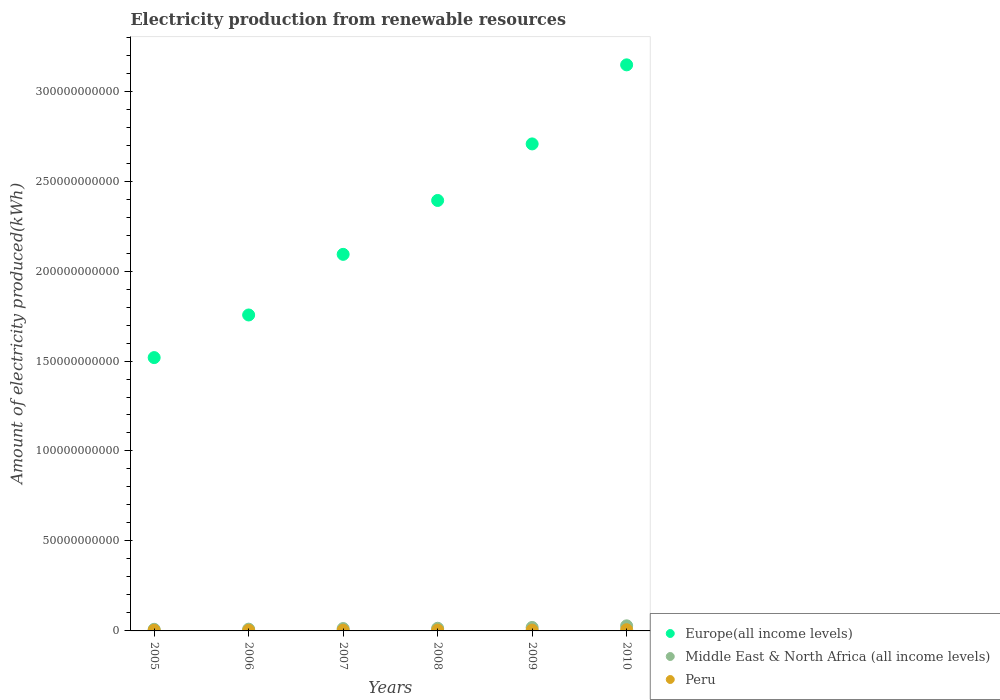Is the number of dotlines equal to the number of legend labels?
Ensure brevity in your answer.  Yes. What is the amount of electricity produced in Europe(all income levels) in 2007?
Give a very brief answer. 2.09e+11. Across all years, what is the maximum amount of electricity produced in Peru?
Provide a short and direct response. 6.74e+08. Across all years, what is the minimum amount of electricity produced in Peru?
Give a very brief answer. 3.49e+08. What is the total amount of electricity produced in Middle East & North Africa (all income levels) in the graph?
Keep it short and to the point. 9.42e+09. What is the difference between the amount of electricity produced in Middle East & North Africa (all income levels) in 2006 and that in 2008?
Your answer should be very brief. -4.93e+08. What is the difference between the amount of electricity produced in Middle East & North Africa (all income levels) in 2006 and the amount of electricity produced in Europe(all income levels) in 2009?
Make the answer very short. -2.70e+11. What is the average amount of electricity produced in Europe(all income levels) per year?
Ensure brevity in your answer.  2.27e+11. In the year 2009, what is the difference between the amount of electricity produced in Middle East & North Africa (all income levels) and amount of electricity produced in Europe(all income levels)?
Keep it short and to the point. -2.69e+11. What is the ratio of the amount of electricity produced in Europe(all income levels) in 2005 to that in 2010?
Your answer should be very brief. 0.48. Is the amount of electricity produced in Peru in 2007 less than that in 2010?
Keep it short and to the point. Yes. Is the difference between the amount of electricity produced in Middle East & North Africa (all income levels) in 2005 and 2010 greater than the difference between the amount of electricity produced in Europe(all income levels) in 2005 and 2010?
Your answer should be compact. Yes. What is the difference between the highest and the second highest amount of electricity produced in Middle East & North Africa (all income levels)?
Keep it short and to the point. 8.95e+08. What is the difference between the highest and the lowest amount of electricity produced in Middle East & North Africa (all income levels)?
Your response must be concise. 1.94e+09. In how many years, is the amount of electricity produced in Peru greater than the average amount of electricity produced in Peru taken over all years?
Provide a succinct answer. 3. Is the sum of the amount of electricity produced in Middle East & North Africa (all income levels) in 2007 and 2010 greater than the maximum amount of electricity produced in Peru across all years?
Make the answer very short. Yes. Does the amount of electricity produced in Europe(all income levels) monotonically increase over the years?
Provide a short and direct response. Yes. Is the amount of electricity produced in Peru strictly greater than the amount of electricity produced in Europe(all income levels) over the years?
Provide a short and direct response. No. How many dotlines are there?
Provide a short and direct response. 3. How many years are there in the graph?
Give a very brief answer. 6. Are the values on the major ticks of Y-axis written in scientific E-notation?
Provide a succinct answer. No. Where does the legend appear in the graph?
Keep it short and to the point. Bottom right. What is the title of the graph?
Give a very brief answer. Electricity production from renewable resources. What is the label or title of the X-axis?
Offer a very short reply. Years. What is the label or title of the Y-axis?
Offer a very short reply. Amount of electricity produced(kWh). What is the Amount of electricity produced(kWh) in Europe(all income levels) in 2005?
Ensure brevity in your answer.  1.52e+11. What is the Amount of electricity produced(kWh) in Middle East & North Africa (all income levels) in 2005?
Provide a short and direct response. 8.90e+08. What is the Amount of electricity produced(kWh) in Peru in 2005?
Offer a very short reply. 3.49e+08. What is the Amount of electricity produced(kWh) in Europe(all income levels) in 2006?
Make the answer very short. 1.76e+11. What is the Amount of electricity produced(kWh) of Middle East & North Africa (all income levels) in 2006?
Your answer should be compact. 9.81e+08. What is the Amount of electricity produced(kWh) of Peru in 2006?
Your answer should be compact. 3.49e+08. What is the Amount of electricity produced(kWh) of Europe(all income levels) in 2007?
Your answer should be very brief. 2.09e+11. What is the Amount of electricity produced(kWh) of Middle East & North Africa (all income levels) in 2007?
Give a very brief answer. 1.32e+09. What is the Amount of electricity produced(kWh) in Peru in 2007?
Your answer should be very brief. 4.18e+08. What is the Amount of electricity produced(kWh) of Europe(all income levels) in 2008?
Your answer should be very brief. 2.39e+11. What is the Amount of electricity produced(kWh) in Middle East & North Africa (all income levels) in 2008?
Offer a very short reply. 1.47e+09. What is the Amount of electricity produced(kWh) in Peru in 2008?
Your response must be concise. 4.61e+08. What is the Amount of electricity produced(kWh) in Europe(all income levels) in 2009?
Your answer should be compact. 2.71e+11. What is the Amount of electricity produced(kWh) in Middle East & North Africa (all income levels) in 2009?
Your response must be concise. 1.93e+09. What is the Amount of electricity produced(kWh) of Peru in 2009?
Your answer should be compact. 4.61e+08. What is the Amount of electricity produced(kWh) of Europe(all income levels) in 2010?
Offer a very short reply. 3.15e+11. What is the Amount of electricity produced(kWh) of Middle East & North Africa (all income levels) in 2010?
Offer a very short reply. 2.83e+09. What is the Amount of electricity produced(kWh) of Peru in 2010?
Offer a terse response. 6.74e+08. Across all years, what is the maximum Amount of electricity produced(kWh) in Europe(all income levels)?
Your response must be concise. 3.15e+11. Across all years, what is the maximum Amount of electricity produced(kWh) of Middle East & North Africa (all income levels)?
Provide a short and direct response. 2.83e+09. Across all years, what is the maximum Amount of electricity produced(kWh) in Peru?
Ensure brevity in your answer.  6.74e+08. Across all years, what is the minimum Amount of electricity produced(kWh) in Europe(all income levels)?
Keep it short and to the point. 1.52e+11. Across all years, what is the minimum Amount of electricity produced(kWh) of Middle East & North Africa (all income levels)?
Provide a short and direct response. 8.90e+08. Across all years, what is the minimum Amount of electricity produced(kWh) of Peru?
Provide a succinct answer. 3.49e+08. What is the total Amount of electricity produced(kWh) in Europe(all income levels) in the graph?
Ensure brevity in your answer.  1.36e+12. What is the total Amount of electricity produced(kWh) of Middle East & North Africa (all income levels) in the graph?
Ensure brevity in your answer.  9.42e+09. What is the total Amount of electricity produced(kWh) in Peru in the graph?
Give a very brief answer. 2.71e+09. What is the difference between the Amount of electricity produced(kWh) in Europe(all income levels) in 2005 and that in 2006?
Ensure brevity in your answer.  -2.37e+1. What is the difference between the Amount of electricity produced(kWh) of Middle East & North Africa (all income levels) in 2005 and that in 2006?
Offer a terse response. -9.10e+07. What is the difference between the Amount of electricity produced(kWh) in Peru in 2005 and that in 2006?
Ensure brevity in your answer.  0. What is the difference between the Amount of electricity produced(kWh) of Europe(all income levels) in 2005 and that in 2007?
Give a very brief answer. -5.74e+1. What is the difference between the Amount of electricity produced(kWh) in Middle East & North Africa (all income levels) in 2005 and that in 2007?
Ensure brevity in your answer.  -4.29e+08. What is the difference between the Amount of electricity produced(kWh) in Peru in 2005 and that in 2007?
Your answer should be very brief. -6.90e+07. What is the difference between the Amount of electricity produced(kWh) of Europe(all income levels) in 2005 and that in 2008?
Offer a terse response. -8.73e+1. What is the difference between the Amount of electricity produced(kWh) in Middle East & North Africa (all income levels) in 2005 and that in 2008?
Your response must be concise. -5.84e+08. What is the difference between the Amount of electricity produced(kWh) in Peru in 2005 and that in 2008?
Provide a succinct answer. -1.12e+08. What is the difference between the Amount of electricity produced(kWh) of Europe(all income levels) in 2005 and that in 2009?
Offer a very short reply. -1.19e+11. What is the difference between the Amount of electricity produced(kWh) of Middle East & North Africa (all income levels) in 2005 and that in 2009?
Give a very brief answer. -1.04e+09. What is the difference between the Amount of electricity produced(kWh) of Peru in 2005 and that in 2009?
Your answer should be very brief. -1.12e+08. What is the difference between the Amount of electricity produced(kWh) of Europe(all income levels) in 2005 and that in 2010?
Offer a terse response. -1.63e+11. What is the difference between the Amount of electricity produced(kWh) of Middle East & North Africa (all income levels) in 2005 and that in 2010?
Ensure brevity in your answer.  -1.94e+09. What is the difference between the Amount of electricity produced(kWh) of Peru in 2005 and that in 2010?
Your answer should be very brief. -3.25e+08. What is the difference between the Amount of electricity produced(kWh) in Europe(all income levels) in 2006 and that in 2007?
Your answer should be very brief. -3.37e+1. What is the difference between the Amount of electricity produced(kWh) in Middle East & North Africa (all income levels) in 2006 and that in 2007?
Your answer should be very brief. -3.38e+08. What is the difference between the Amount of electricity produced(kWh) in Peru in 2006 and that in 2007?
Give a very brief answer. -6.90e+07. What is the difference between the Amount of electricity produced(kWh) in Europe(all income levels) in 2006 and that in 2008?
Ensure brevity in your answer.  -6.36e+1. What is the difference between the Amount of electricity produced(kWh) of Middle East & North Africa (all income levels) in 2006 and that in 2008?
Provide a succinct answer. -4.93e+08. What is the difference between the Amount of electricity produced(kWh) of Peru in 2006 and that in 2008?
Your answer should be very brief. -1.12e+08. What is the difference between the Amount of electricity produced(kWh) of Europe(all income levels) in 2006 and that in 2009?
Ensure brevity in your answer.  -9.51e+1. What is the difference between the Amount of electricity produced(kWh) of Middle East & North Africa (all income levels) in 2006 and that in 2009?
Give a very brief answer. -9.52e+08. What is the difference between the Amount of electricity produced(kWh) of Peru in 2006 and that in 2009?
Provide a succinct answer. -1.12e+08. What is the difference between the Amount of electricity produced(kWh) in Europe(all income levels) in 2006 and that in 2010?
Ensure brevity in your answer.  -1.39e+11. What is the difference between the Amount of electricity produced(kWh) of Middle East & North Africa (all income levels) in 2006 and that in 2010?
Keep it short and to the point. -1.85e+09. What is the difference between the Amount of electricity produced(kWh) in Peru in 2006 and that in 2010?
Provide a short and direct response. -3.25e+08. What is the difference between the Amount of electricity produced(kWh) in Europe(all income levels) in 2007 and that in 2008?
Give a very brief answer. -3.00e+1. What is the difference between the Amount of electricity produced(kWh) of Middle East & North Africa (all income levels) in 2007 and that in 2008?
Offer a terse response. -1.55e+08. What is the difference between the Amount of electricity produced(kWh) of Peru in 2007 and that in 2008?
Offer a very short reply. -4.30e+07. What is the difference between the Amount of electricity produced(kWh) of Europe(all income levels) in 2007 and that in 2009?
Offer a terse response. -6.14e+1. What is the difference between the Amount of electricity produced(kWh) in Middle East & North Africa (all income levels) in 2007 and that in 2009?
Provide a short and direct response. -6.14e+08. What is the difference between the Amount of electricity produced(kWh) of Peru in 2007 and that in 2009?
Provide a succinct answer. -4.30e+07. What is the difference between the Amount of electricity produced(kWh) in Europe(all income levels) in 2007 and that in 2010?
Your answer should be very brief. -1.05e+11. What is the difference between the Amount of electricity produced(kWh) in Middle East & North Africa (all income levels) in 2007 and that in 2010?
Your answer should be compact. -1.51e+09. What is the difference between the Amount of electricity produced(kWh) of Peru in 2007 and that in 2010?
Make the answer very short. -2.56e+08. What is the difference between the Amount of electricity produced(kWh) in Europe(all income levels) in 2008 and that in 2009?
Provide a short and direct response. -3.14e+1. What is the difference between the Amount of electricity produced(kWh) in Middle East & North Africa (all income levels) in 2008 and that in 2009?
Offer a very short reply. -4.59e+08. What is the difference between the Amount of electricity produced(kWh) of Peru in 2008 and that in 2009?
Provide a succinct answer. 0. What is the difference between the Amount of electricity produced(kWh) in Europe(all income levels) in 2008 and that in 2010?
Keep it short and to the point. -7.54e+1. What is the difference between the Amount of electricity produced(kWh) of Middle East & North Africa (all income levels) in 2008 and that in 2010?
Provide a succinct answer. -1.35e+09. What is the difference between the Amount of electricity produced(kWh) of Peru in 2008 and that in 2010?
Offer a terse response. -2.13e+08. What is the difference between the Amount of electricity produced(kWh) in Europe(all income levels) in 2009 and that in 2010?
Offer a very short reply. -4.39e+1. What is the difference between the Amount of electricity produced(kWh) in Middle East & North Africa (all income levels) in 2009 and that in 2010?
Ensure brevity in your answer.  -8.95e+08. What is the difference between the Amount of electricity produced(kWh) in Peru in 2009 and that in 2010?
Provide a short and direct response. -2.13e+08. What is the difference between the Amount of electricity produced(kWh) of Europe(all income levels) in 2005 and the Amount of electricity produced(kWh) of Middle East & North Africa (all income levels) in 2006?
Your answer should be very brief. 1.51e+11. What is the difference between the Amount of electricity produced(kWh) of Europe(all income levels) in 2005 and the Amount of electricity produced(kWh) of Peru in 2006?
Make the answer very short. 1.52e+11. What is the difference between the Amount of electricity produced(kWh) in Middle East & North Africa (all income levels) in 2005 and the Amount of electricity produced(kWh) in Peru in 2006?
Your response must be concise. 5.41e+08. What is the difference between the Amount of electricity produced(kWh) of Europe(all income levels) in 2005 and the Amount of electricity produced(kWh) of Middle East & North Africa (all income levels) in 2007?
Provide a short and direct response. 1.51e+11. What is the difference between the Amount of electricity produced(kWh) of Europe(all income levels) in 2005 and the Amount of electricity produced(kWh) of Peru in 2007?
Your answer should be very brief. 1.51e+11. What is the difference between the Amount of electricity produced(kWh) in Middle East & North Africa (all income levels) in 2005 and the Amount of electricity produced(kWh) in Peru in 2007?
Ensure brevity in your answer.  4.72e+08. What is the difference between the Amount of electricity produced(kWh) in Europe(all income levels) in 2005 and the Amount of electricity produced(kWh) in Middle East & North Africa (all income levels) in 2008?
Keep it short and to the point. 1.50e+11. What is the difference between the Amount of electricity produced(kWh) of Europe(all income levels) in 2005 and the Amount of electricity produced(kWh) of Peru in 2008?
Offer a very short reply. 1.51e+11. What is the difference between the Amount of electricity produced(kWh) of Middle East & North Africa (all income levels) in 2005 and the Amount of electricity produced(kWh) of Peru in 2008?
Your answer should be very brief. 4.29e+08. What is the difference between the Amount of electricity produced(kWh) of Europe(all income levels) in 2005 and the Amount of electricity produced(kWh) of Middle East & North Africa (all income levels) in 2009?
Provide a short and direct response. 1.50e+11. What is the difference between the Amount of electricity produced(kWh) of Europe(all income levels) in 2005 and the Amount of electricity produced(kWh) of Peru in 2009?
Make the answer very short. 1.51e+11. What is the difference between the Amount of electricity produced(kWh) in Middle East & North Africa (all income levels) in 2005 and the Amount of electricity produced(kWh) in Peru in 2009?
Ensure brevity in your answer.  4.29e+08. What is the difference between the Amount of electricity produced(kWh) in Europe(all income levels) in 2005 and the Amount of electricity produced(kWh) in Middle East & North Africa (all income levels) in 2010?
Provide a succinct answer. 1.49e+11. What is the difference between the Amount of electricity produced(kWh) in Europe(all income levels) in 2005 and the Amount of electricity produced(kWh) in Peru in 2010?
Your answer should be very brief. 1.51e+11. What is the difference between the Amount of electricity produced(kWh) of Middle East & North Africa (all income levels) in 2005 and the Amount of electricity produced(kWh) of Peru in 2010?
Offer a very short reply. 2.16e+08. What is the difference between the Amount of electricity produced(kWh) of Europe(all income levels) in 2006 and the Amount of electricity produced(kWh) of Middle East & North Africa (all income levels) in 2007?
Ensure brevity in your answer.  1.74e+11. What is the difference between the Amount of electricity produced(kWh) of Europe(all income levels) in 2006 and the Amount of electricity produced(kWh) of Peru in 2007?
Offer a very short reply. 1.75e+11. What is the difference between the Amount of electricity produced(kWh) of Middle East & North Africa (all income levels) in 2006 and the Amount of electricity produced(kWh) of Peru in 2007?
Your answer should be very brief. 5.63e+08. What is the difference between the Amount of electricity produced(kWh) in Europe(all income levels) in 2006 and the Amount of electricity produced(kWh) in Middle East & North Africa (all income levels) in 2008?
Give a very brief answer. 1.74e+11. What is the difference between the Amount of electricity produced(kWh) in Europe(all income levels) in 2006 and the Amount of electricity produced(kWh) in Peru in 2008?
Offer a very short reply. 1.75e+11. What is the difference between the Amount of electricity produced(kWh) in Middle East & North Africa (all income levels) in 2006 and the Amount of electricity produced(kWh) in Peru in 2008?
Provide a short and direct response. 5.20e+08. What is the difference between the Amount of electricity produced(kWh) of Europe(all income levels) in 2006 and the Amount of electricity produced(kWh) of Middle East & North Africa (all income levels) in 2009?
Keep it short and to the point. 1.74e+11. What is the difference between the Amount of electricity produced(kWh) in Europe(all income levels) in 2006 and the Amount of electricity produced(kWh) in Peru in 2009?
Keep it short and to the point. 1.75e+11. What is the difference between the Amount of electricity produced(kWh) in Middle East & North Africa (all income levels) in 2006 and the Amount of electricity produced(kWh) in Peru in 2009?
Ensure brevity in your answer.  5.20e+08. What is the difference between the Amount of electricity produced(kWh) in Europe(all income levels) in 2006 and the Amount of electricity produced(kWh) in Middle East & North Africa (all income levels) in 2010?
Give a very brief answer. 1.73e+11. What is the difference between the Amount of electricity produced(kWh) in Europe(all income levels) in 2006 and the Amount of electricity produced(kWh) in Peru in 2010?
Keep it short and to the point. 1.75e+11. What is the difference between the Amount of electricity produced(kWh) of Middle East & North Africa (all income levels) in 2006 and the Amount of electricity produced(kWh) of Peru in 2010?
Your answer should be compact. 3.07e+08. What is the difference between the Amount of electricity produced(kWh) of Europe(all income levels) in 2007 and the Amount of electricity produced(kWh) of Middle East & North Africa (all income levels) in 2008?
Your answer should be very brief. 2.08e+11. What is the difference between the Amount of electricity produced(kWh) in Europe(all income levels) in 2007 and the Amount of electricity produced(kWh) in Peru in 2008?
Ensure brevity in your answer.  2.09e+11. What is the difference between the Amount of electricity produced(kWh) of Middle East & North Africa (all income levels) in 2007 and the Amount of electricity produced(kWh) of Peru in 2008?
Keep it short and to the point. 8.58e+08. What is the difference between the Amount of electricity produced(kWh) in Europe(all income levels) in 2007 and the Amount of electricity produced(kWh) in Middle East & North Africa (all income levels) in 2009?
Give a very brief answer. 2.07e+11. What is the difference between the Amount of electricity produced(kWh) in Europe(all income levels) in 2007 and the Amount of electricity produced(kWh) in Peru in 2009?
Ensure brevity in your answer.  2.09e+11. What is the difference between the Amount of electricity produced(kWh) in Middle East & North Africa (all income levels) in 2007 and the Amount of electricity produced(kWh) in Peru in 2009?
Your response must be concise. 8.58e+08. What is the difference between the Amount of electricity produced(kWh) in Europe(all income levels) in 2007 and the Amount of electricity produced(kWh) in Middle East & North Africa (all income levels) in 2010?
Provide a succinct answer. 2.06e+11. What is the difference between the Amount of electricity produced(kWh) of Europe(all income levels) in 2007 and the Amount of electricity produced(kWh) of Peru in 2010?
Your answer should be very brief. 2.09e+11. What is the difference between the Amount of electricity produced(kWh) of Middle East & North Africa (all income levels) in 2007 and the Amount of electricity produced(kWh) of Peru in 2010?
Offer a very short reply. 6.45e+08. What is the difference between the Amount of electricity produced(kWh) of Europe(all income levels) in 2008 and the Amount of electricity produced(kWh) of Middle East & North Africa (all income levels) in 2009?
Your answer should be very brief. 2.37e+11. What is the difference between the Amount of electricity produced(kWh) of Europe(all income levels) in 2008 and the Amount of electricity produced(kWh) of Peru in 2009?
Provide a succinct answer. 2.39e+11. What is the difference between the Amount of electricity produced(kWh) of Middle East & North Africa (all income levels) in 2008 and the Amount of electricity produced(kWh) of Peru in 2009?
Offer a terse response. 1.01e+09. What is the difference between the Amount of electricity produced(kWh) in Europe(all income levels) in 2008 and the Amount of electricity produced(kWh) in Middle East & North Africa (all income levels) in 2010?
Your answer should be compact. 2.36e+11. What is the difference between the Amount of electricity produced(kWh) of Europe(all income levels) in 2008 and the Amount of electricity produced(kWh) of Peru in 2010?
Keep it short and to the point. 2.39e+11. What is the difference between the Amount of electricity produced(kWh) of Middle East & North Africa (all income levels) in 2008 and the Amount of electricity produced(kWh) of Peru in 2010?
Provide a succinct answer. 8.00e+08. What is the difference between the Amount of electricity produced(kWh) in Europe(all income levels) in 2009 and the Amount of electricity produced(kWh) in Middle East & North Africa (all income levels) in 2010?
Offer a terse response. 2.68e+11. What is the difference between the Amount of electricity produced(kWh) of Europe(all income levels) in 2009 and the Amount of electricity produced(kWh) of Peru in 2010?
Your answer should be very brief. 2.70e+11. What is the difference between the Amount of electricity produced(kWh) in Middle East & North Africa (all income levels) in 2009 and the Amount of electricity produced(kWh) in Peru in 2010?
Offer a very short reply. 1.26e+09. What is the average Amount of electricity produced(kWh) of Europe(all income levels) per year?
Give a very brief answer. 2.27e+11. What is the average Amount of electricity produced(kWh) of Middle East & North Africa (all income levels) per year?
Ensure brevity in your answer.  1.57e+09. What is the average Amount of electricity produced(kWh) of Peru per year?
Offer a terse response. 4.52e+08. In the year 2005, what is the difference between the Amount of electricity produced(kWh) in Europe(all income levels) and Amount of electricity produced(kWh) in Middle East & North Africa (all income levels)?
Offer a very short reply. 1.51e+11. In the year 2005, what is the difference between the Amount of electricity produced(kWh) in Europe(all income levels) and Amount of electricity produced(kWh) in Peru?
Offer a very short reply. 1.52e+11. In the year 2005, what is the difference between the Amount of electricity produced(kWh) in Middle East & North Africa (all income levels) and Amount of electricity produced(kWh) in Peru?
Make the answer very short. 5.41e+08. In the year 2006, what is the difference between the Amount of electricity produced(kWh) in Europe(all income levels) and Amount of electricity produced(kWh) in Middle East & North Africa (all income levels)?
Offer a terse response. 1.75e+11. In the year 2006, what is the difference between the Amount of electricity produced(kWh) in Europe(all income levels) and Amount of electricity produced(kWh) in Peru?
Make the answer very short. 1.75e+11. In the year 2006, what is the difference between the Amount of electricity produced(kWh) of Middle East & North Africa (all income levels) and Amount of electricity produced(kWh) of Peru?
Ensure brevity in your answer.  6.32e+08. In the year 2007, what is the difference between the Amount of electricity produced(kWh) in Europe(all income levels) and Amount of electricity produced(kWh) in Middle East & North Africa (all income levels)?
Keep it short and to the point. 2.08e+11. In the year 2007, what is the difference between the Amount of electricity produced(kWh) in Europe(all income levels) and Amount of electricity produced(kWh) in Peru?
Keep it short and to the point. 2.09e+11. In the year 2007, what is the difference between the Amount of electricity produced(kWh) of Middle East & North Africa (all income levels) and Amount of electricity produced(kWh) of Peru?
Provide a succinct answer. 9.01e+08. In the year 2008, what is the difference between the Amount of electricity produced(kWh) in Europe(all income levels) and Amount of electricity produced(kWh) in Middle East & North Africa (all income levels)?
Offer a very short reply. 2.38e+11. In the year 2008, what is the difference between the Amount of electricity produced(kWh) in Europe(all income levels) and Amount of electricity produced(kWh) in Peru?
Provide a short and direct response. 2.39e+11. In the year 2008, what is the difference between the Amount of electricity produced(kWh) of Middle East & North Africa (all income levels) and Amount of electricity produced(kWh) of Peru?
Make the answer very short. 1.01e+09. In the year 2009, what is the difference between the Amount of electricity produced(kWh) of Europe(all income levels) and Amount of electricity produced(kWh) of Middle East & North Africa (all income levels)?
Your answer should be compact. 2.69e+11. In the year 2009, what is the difference between the Amount of electricity produced(kWh) in Europe(all income levels) and Amount of electricity produced(kWh) in Peru?
Provide a succinct answer. 2.70e+11. In the year 2009, what is the difference between the Amount of electricity produced(kWh) in Middle East & North Africa (all income levels) and Amount of electricity produced(kWh) in Peru?
Offer a very short reply. 1.47e+09. In the year 2010, what is the difference between the Amount of electricity produced(kWh) in Europe(all income levels) and Amount of electricity produced(kWh) in Middle East & North Africa (all income levels)?
Keep it short and to the point. 3.12e+11. In the year 2010, what is the difference between the Amount of electricity produced(kWh) of Europe(all income levels) and Amount of electricity produced(kWh) of Peru?
Your response must be concise. 3.14e+11. In the year 2010, what is the difference between the Amount of electricity produced(kWh) in Middle East & North Africa (all income levels) and Amount of electricity produced(kWh) in Peru?
Make the answer very short. 2.15e+09. What is the ratio of the Amount of electricity produced(kWh) in Europe(all income levels) in 2005 to that in 2006?
Offer a very short reply. 0.87. What is the ratio of the Amount of electricity produced(kWh) in Middle East & North Africa (all income levels) in 2005 to that in 2006?
Your response must be concise. 0.91. What is the ratio of the Amount of electricity produced(kWh) of Europe(all income levels) in 2005 to that in 2007?
Offer a very short reply. 0.73. What is the ratio of the Amount of electricity produced(kWh) of Middle East & North Africa (all income levels) in 2005 to that in 2007?
Make the answer very short. 0.67. What is the ratio of the Amount of electricity produced(kWh) in Peru in 2005 to that in 2007?
Make the answer very short. 0.83. What is the ratio of the Amount of electricity produced(kWh) in Europe(all income levels) in 2005 to that in 2008?
Offer a terse response. 0.64. What is the ratio of the Amount of electricity produced(kWh) in Middle East & North Africa (all income levels) in 2005 to that in 2008?
Your answer should be very brief. 0.6. What is the ratio of the Amount of electricity produced(kWh) in Peru in 2005 to that in 2008?
Offer a very short reply. 0.76. What is the ratio of the Amount of electricity produced(kWh) of Europe(all income levels) in 2005 to that in 2009?
Provide a succinct answer. 0.56. What is the ratio of the Amount of electricity produced(kWh) in Middle East & North Africa (all income levels) in 2005 to that in 2009?
Keep it short and to the point. 0.46. What is the ratio of the Amount of electricity produced(kWh) in Peru in 2005 to that in 2009?
Give a very brief answer. 0.76. What is the ratio of the Amount of electricity produced(kWh) in Europe(all income levels) in 2005 to that in 2010?
Provide a short and direct response. 0.48. What is the ratio of the Amount of electricity produced(kWh) in Middle East & North Africa (all income levels) in 2005 to that in 2010?
Provide a short and direct response. 0.31. What is the ratio of the Amount of electricity produced(kWh) in Peru in 2005 to that in 2010?
Give a very brief answer. 0.52. What is the ratio of the Amount of electricity produced(kWh) of Europe(all income levels) in 2006 to that in 2007?
Offer a very short reply. 0.84. What is the ratio of the Amount of electricity produced(kWh) in Middle East & North Africa (all income levels) in 2006 to that in 2007?
Ensure brevity in your answer.  0.74. What is the ratio of the Amount of electricity produced(kWh) of Peru in 2006 to that in 2007?
Offer a terse response. 0.83. What is the ratio of the Amount of electricity produced(kWh) of Europe(all income levels) in 2006 to that in 2008?
Ensure brevity in your answer.  0.73. What is the ratio of the Amount of electricity produced(kWh) of Middle East & North Africa (all income levels) in 2006 to that in 2008?
Keep it short and to the point. 0.67. What is the ratio of the Amount of electricity produced(kWh) in Peru in 2006 to that in 2008?
Keep it short and to the point. 0.76. What is the ratio of the Amount of electricity produced(kWh) of Europe(all income levels) in 2006 to that in 2009?
Your response must be concise. 0.65. What is the ratio of the Amount of electricity produced(kWh) of Middle East & North Africa (all income levels) in 2006 to that in 2009?
Offer a terse response. 0.51. What is the ratio of the Amount of electricity produced(kWh) in Peru in 2006 to that in 2009?
Ensure brevity in your answer.  0.76. What is the ratio of the Amount of electricity produced(kWh) of Europe(all income levels) in 2006 to that in 2010?
Offer a terse response. 0.56. What is the ratio of the Amount of electricity produced(kWh) in Middle East & North Africa (all income levels) in 2006 to that in 2010?
Give a very brief answer. 0.35. What is the ratio of the Amount of electricity produced(kWh) of Peru in 2006 to that in 2010?
Ensure brevity in your answer.  0.52. What is the ratio of the Amount of electricity produced(kWh) of Europe(all income levels) in 2007 to that in 2008?
Your response must be concise. 0.87. What is the ratio of the Amount of electricity produced(kWh) of Middle East & North Africa (all income levels) in 2007 to that in 2008?
Keep it short and to the point. 0.89. What is the ratio of the Amount of electricity produced(kWh) in Peru in 2007 to that in 2008?
Give a very brief answer. 0.91. What is the ratio of the Amount of electricity produced(kWh) in Europe(all income levels) in 2007 to that in 2009?
Provide a short and direct response. 0.77. What is the ratio of the Amount of electricity produced(kWh) of Middle East & North Africa (all income levels) in 2007 to that in 2009?
Your answer should be very brief. 0.68. What is the ratio of the Amount of electricity produced(kWh) of Peru in 2007 to that in 2009?
Give a very brief answer. 0.91. What is the ratio of the Amount of electricity produced(kWh) of Europe(all income levels) in 2007 to that in 2010?
Your answer should be very brief. 0.67. What is the ratio of the Amount of electricity produced(kWh) in Middle East & North Africa (all income levels) in 2007 to that in 2010?
Give a very brief answer. 0.47. What is the ratio of the Amount of electricity produced(kWh) in Peru in 2007 to that in 2010?
Your response must be concise. 0.62. What is the ratio of the Amount of electricity produced(kWh) in Europe(all income levels) in 2008 to that in 2009?
Your response must be concise. 0.88. What is the ratio of the Amount of electricity produced(kWh) in Middle East & North Africa (all income levels) in 2008 to that in 2009?
Keep it short and to the point. 0.76. What is the ratio of the Amount of electricity produced(kWh) in Europe(all income levels) in 2008 to that in 2010?
Your answer should be very brief. 0.76. What is the ratio of the Amount of electricity produced(kWh) of Middle East & North Africa (all income levels) in 2008 to that in 2010?
Provide a short and direct response. 0.52. What is the ratio of the Amount of electricity produced(kWh) in Peru in 2008 to that in 2010?
Your answer should be compact. 0.68. What is the ratio of the Amount of electricity produced(kWh) in Europe(all income levels) in 2009 to that in 2010?
Your answer should be very brief. 0.86. What is the ratio of the Amount of electricity produced(kWh) of Middle East & North Africa (all income levels) in 2009 to that in 2010?
Keep it short and to the point. 0.68. What is the ratio of the Amount of electricity produced(kWh) in Peru in 2009 to that in 2010?
Your answer should be very brief. 0.68. What is the difference between the highest and the second highest Amount of electricity produced(kWh) in Europe(all income levels)?
Your answer should be very brief. 4.39e+1. What is the difference between the highest and the second highest Amount of electricity produced(kWh) of Middle East & North Africa (all income levels)?
Offer a terse response. 8.95e+08. What is the difference between the highest and the second highest Amount of electricity produced(kWh) of Peru?
Ensure brevity in your answer.  2.13e+08. What is the difference between the highest and the lowest Amount of electricity produced(kWh) in Europe(all income levels)?
Provide a short and direct response. 1.63e+11. What is the difference between the highest and the lowest Amount of electricity produced(kWh) in Middle East & North Africa (all income levels)?
Make the answer very short. 1.94e+09. What is the difference between the highest and the lowest Amount of electricity produced(kWh) of Peru?
Ensure brevity in your answer.  3.25e+08. 